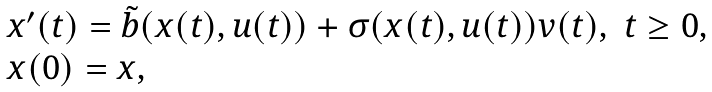Convert formula to latex. <formula><loc_0><loc_0><loc_500><loc_500>\begin{array} { l l } x ^ { \prime } ( t ) = \tilde { b } ( x ( t ) , u ( t ) ) + \sigma ( x ( t ) , u ( t ) ) v ( t ) , & t \geq 0 , \\ x ( 0 ) = x , \end{array}</formula> 